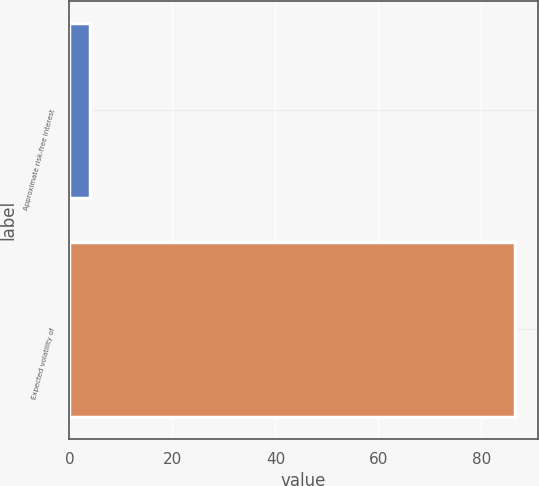Convert chart to OTSL. <chart><loc_0><loc_0><loc_500><loc_500><bar_chart><fcel>Approximate risk-free interest<fcel>Expected volatility of<nl><fcel>4<fcel>86.6<nl></chart> 